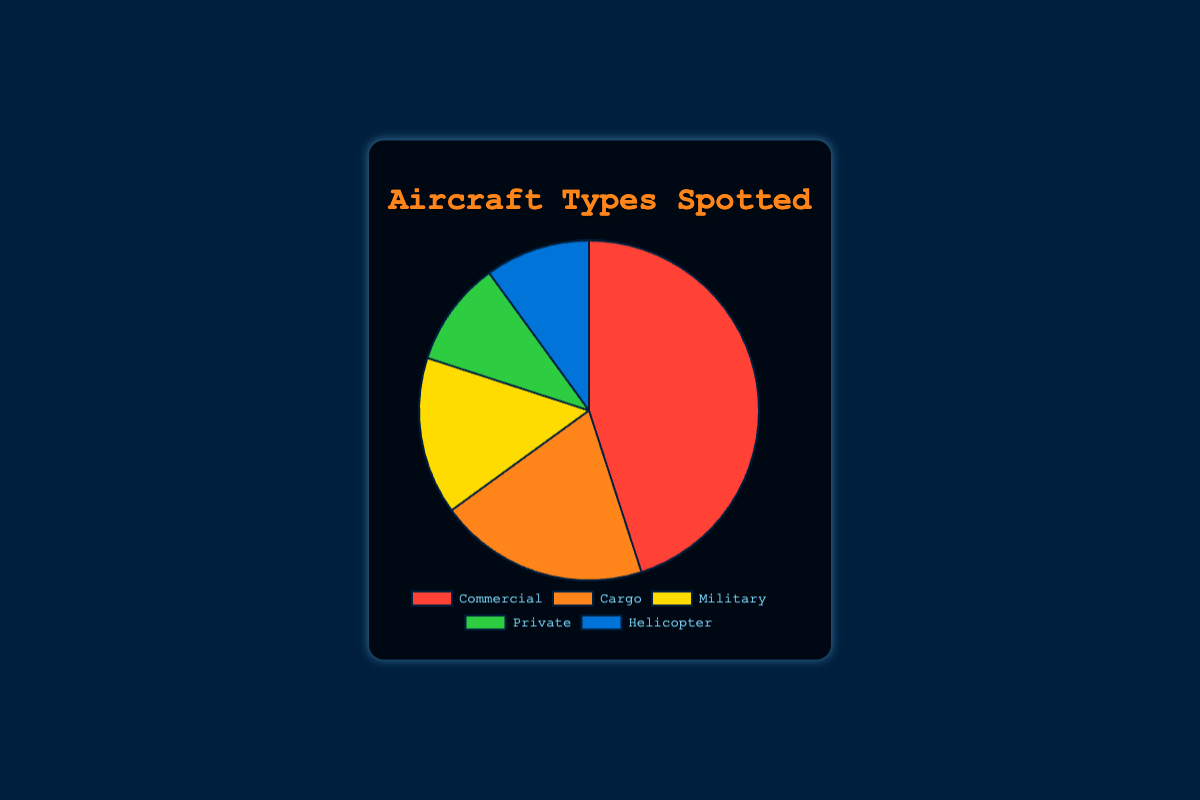What's the most commonly spotted aircraft type? The pie chart shows that the largest segment is for Commercial aircraft, which occupies 45% of the chart.
Answer: Commercial Compare the percentages of Cargo and Military aircraft types. Which one is bigger? The chart shows that Cargo aircraft have a percentage of 20% while Military aircraft have a percentage of 15%. Therefore, Cargo aircraft are more frequently spotted.
Answer: Cargo What percentage of aircraft spotted are either Private or Helicopters? Adding the percentage values for Private (10%) and Helicopters (10%): 10% + 10% = 20%.
Answer: 20% How much greater is the percentage of Commercial aircraft compared to Cargo aircraft? Subtract the percentage of Cargo aircraft (20%) from the percentage of Commercial aircraft (45%): 45% - 20% = 25%.
Answer: 25% Which aircraft types have the smallest percentage and what is their value? The pie chart indicates that both Private and Helicopter aircraft types share the smallest percentage, each with 10%.
Answer: Private and Helicopter, 10% What is the total percentage of non-commercial aircraft types spotted (sum of Cargo, Military, Private, and Helicopters)? Summing up the percentages of Cargo (20%), Military (15%), Private (10%), and Helicopters (10%): 20% + 15% + 10% + 10% = 55%.
Answer: 55% If the Commercial aircraft segment was increased by 5%, what would the new total percentage be? Adding 5% to the original Commercial aircraft percentage (45%): 45% + 5% = 50%.
Answer: 50% Is the sum of Helicopters and Military aircraft percentages greater than the percentage of Cargo aircraft? Adding the percentage values for Helicopters (10%) and Military (15%): 10% + 15% = 25%, which is greater than the Cargo aircraft percentage of 20%.
Answer: Yes If the Military aircraft percentage was reduced by 5%, what would be the new percentage? Subtracting 5% from the Military aircraft percentage (15%): 15% - 5% = 10%.
Answer: 10% What color represents the Private aircraft type in the pie chart? The visual representation of the pie chart shows that the Private aircraft type is marked by a green segment.
Answer: Green 